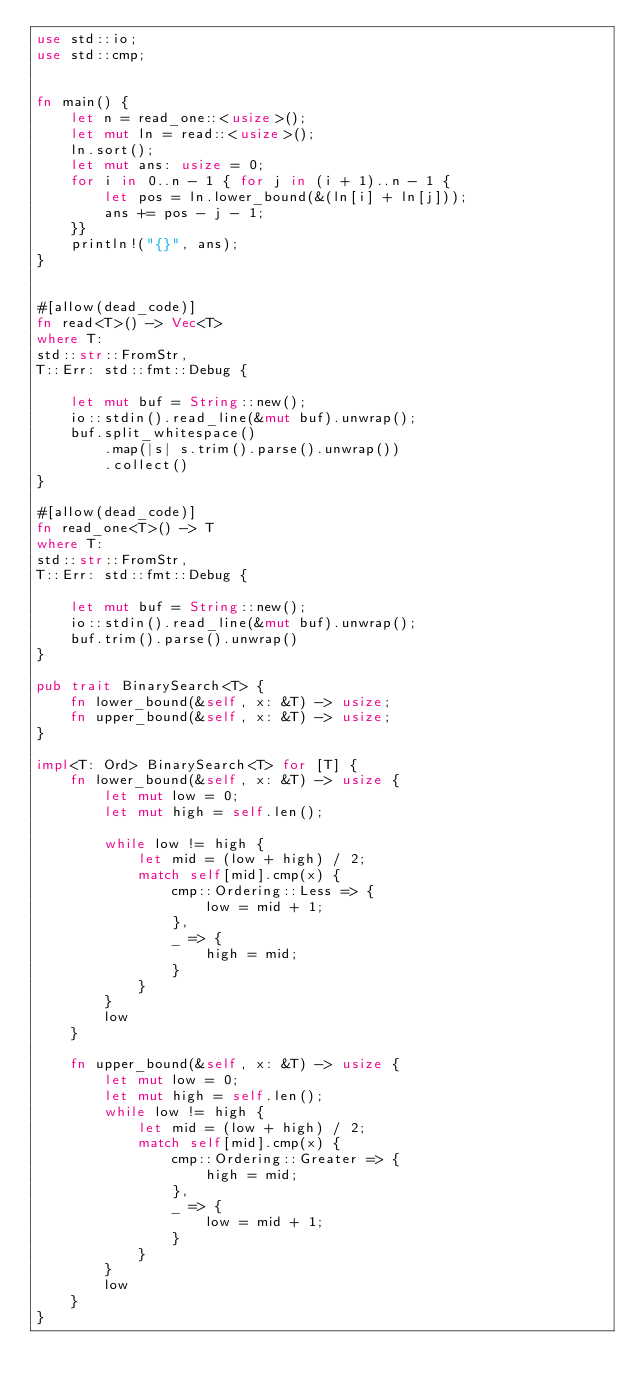<code> <loc_0><loc_0><loc_500><loc_500><_Rust_>use std::io;
use std::cmp;


fn main() {
    let n = read_one::<usize>();
    let mut ln = read::<usize>();
    ln.sort();
    let mut ans: usize = 0;
    for i in 0..n - 1 { for j in (i + 1)..n - 1 {
        let pos = ln.lower_bound(&(ln[i] + ln[j]));
        ans += pos - j - 1;
    }}
    println!("{}", ans);
}


#[allow(dead_code)]
fn read<T>() -> Vec<T>
where T:
std::str::FromStr,
T::Err: std::fmt::Debug {

    let mut buf = String::new();
    io::stdin().read_line(&mut buf).unwrap();
    buf.split_whitespace()
        .map(|s| s.trim().parse().unwrap())
        .collect()
}

#[allow(dead_code)]
fn read_one<T>() -> T
where T:
std::str::FromStr,
T::Err: std::fmt::Debug {

    let mut buf = String::new();
    io::stdin().read_line(&mut buf).unwrap();
    buf.trim().parse().unwrap()
}

pub trait BinarySearch<T> {
    fn lower_bound(&self, x: &T) -> usize;
    fn upper_bound(&self, x: &T) -> usize;
}

impl<T: Ord> BinarySearch<T> for [T] {
    fn lower_bound(&self, x: &T) -> usize {
        let mut low = 0;
        let mut high = self.len();

        while low != high {
            let mid = (low + high) / 2;
            match self[mid].cmp(x) {
                cmp::Ordering::Less => {
                    low = mid + 1;
                },
                _ => {
                    high = mid;
                }
            }
        }
        low
    }

    fn upper_bound(&self, x: &T) -> usize {
        let mut low = 0;
        let mut high = self.len();
        while low != high {
            let mid = (low + high) / 2;
            match self[mid].cmp(x) {
                cmp::Ordering::Greater => {
                    high = mid;
                },
                _ => {
                    low = mid + 1;
                }
            }
        }
        low
    }
}</code> 